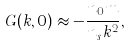Convert formula to latex. <formula><loc_0><loc_0><loc_500><loc_500>G ( { k } , 0 ) \approx - \frac { n _ { 0 } m } { n _ { s } k ^ { 2 } } ,</formula> 